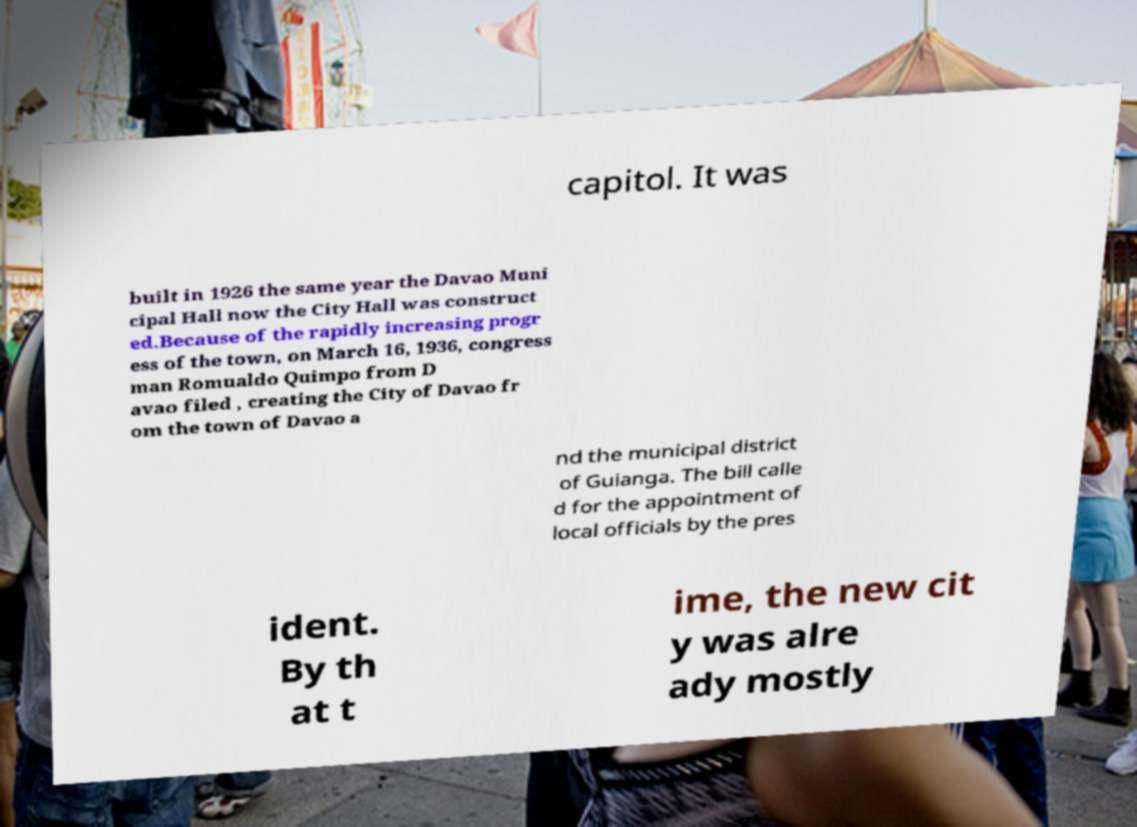There's text embedded in this image that I need extracted. Can you transcribe it verbatim? capitol. It was built in 1926 the same year the Davao Muni cipal Hall now the City Hall was construct ed.Because of the rapidly increasing progr ess of the town, on March 16, 1936, congress man Romualdo Quimpo from D avao filed , creating the City of Davao fr om the town of Davao a nd the municipal district of Guianga. The bill calle d for the appointment of local officials by the pres ident. By th at t ime, the new cit y was alre ady mostly 